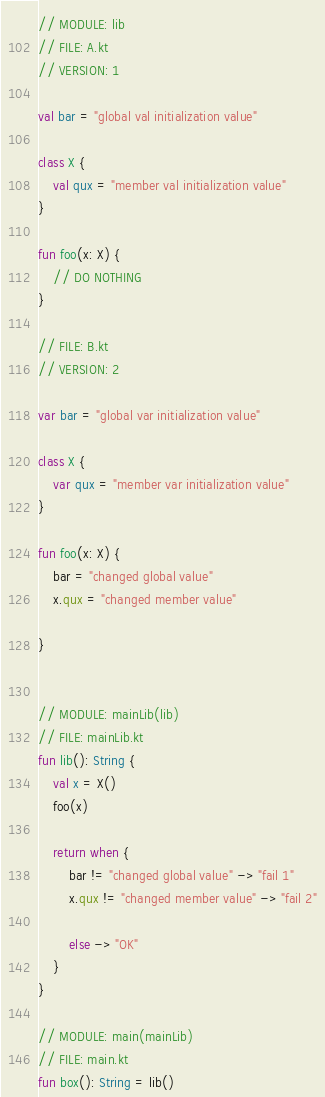<code> <loc_0><loc_0><loc_500><loc_500><_Kotlin_>// MODULE: lib
// FILE: A.kt
// VERSION: 1

val bar = "global val initialization value"

class X {
    val qux = "member val initialization value"
}

fun foo(x: X) {
    // DO NOTHING
}

// FILE: B.kt
// VERSION: 2

var bar = "global var initialization value"

class X {
    var qux = "member var initialization value"
}

fun foo(x: X) {
    bar = "changed global value"
    x.qux = "changed member value"
    
}


// MODULE: mainLib(lib)
// FILE: mainLib.kt
fun lib(): String {
    val x = X()
    foo(x)

    return when {
        bar != "changed global value" -> "fail 1"
        x.qux != "changed member value" -> "fail 2"

        else -> "OK"
    }
}

// MODULE: main(mainLib)
// FILE: main.kt
fun box(): String = lib()

</code> 